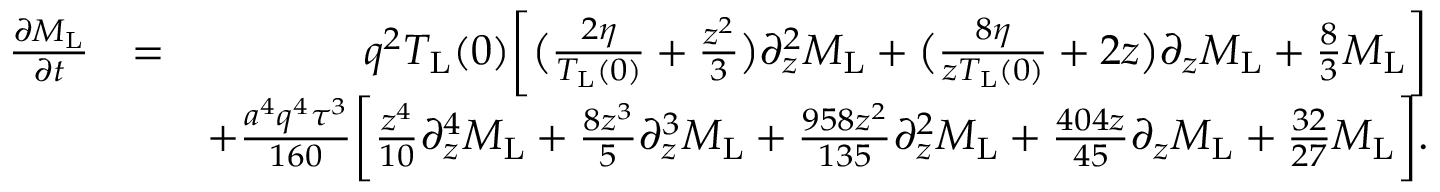Convert formula to latex. <formula><loc_0><loc_0><loc_500><loc_500>\begin{array} { r l r } { \frac { \partial M _ { L } } { \partial t } } & { = } & { q ^ { 2 } T _ { L } ( 0 ) \left [ \left ( \frac { 2 \eta } { T _ { L } ( 0 ) } + \frac { z ^ { 2 } } { 3 } \right ) \partial _ { z } ^ { 2 } M _ { L } + \left ( \frac { 8 \eta } { z T _ { L } ( 0 ) } + 2 z \right ) \partial _ { z } M _ { L } + \frac { 8 } { 3 } M _ { L } \right ] } \\ & { + \frac { a ^ { 4 } q ^ { 4 } \tau ^ { 3 } } { 1 6 0 } \left [ \frac { z ^ { 4 } } { 1 0 } \partial _ { z } ^ { 4 } M _ { L } + \frac { 8 z ^ { 3 } } { 5 } \partial _ { z } ^ { 3 } M _ { L } + \frac { 9 5 8 z ^ { 2 } } { 1 3 5 } \partial _ { z } ^ { 2 } M _ { L } + \frac { 4 0 4 z } { 4 5 } \partial _ { z } M _ { L } + \frac { 3 2 } { 2 7 } M _ { L } \right ] . } \end{array}</formula> 